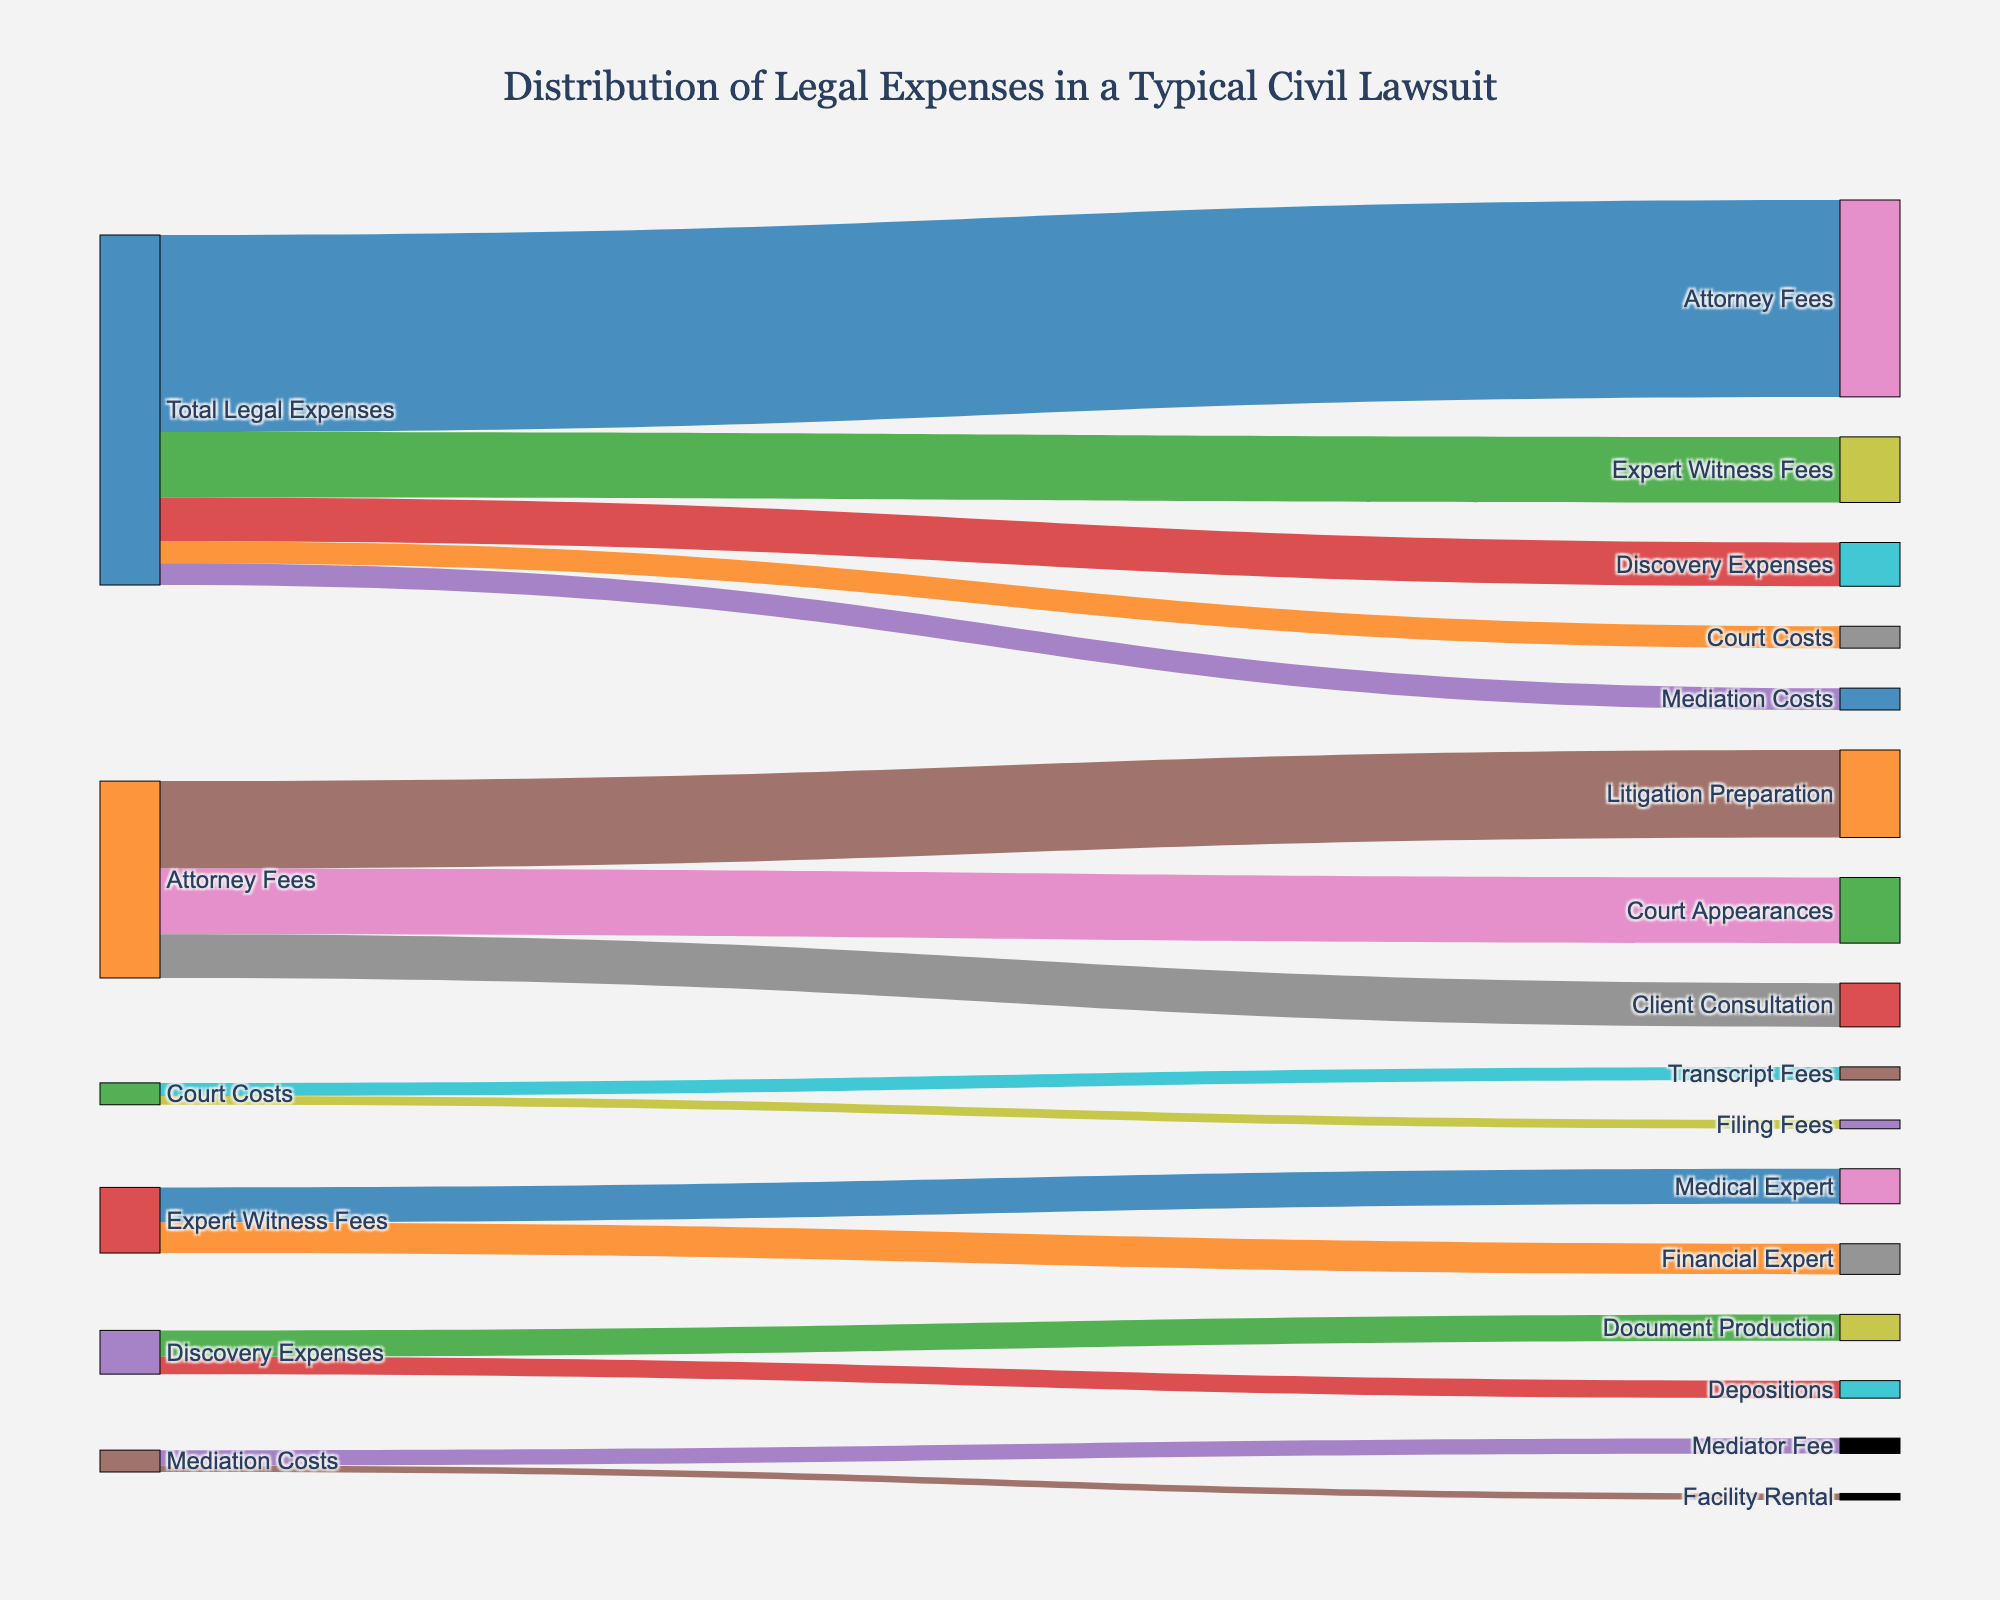What is the title of the figure? The title of the figure is located at the top center and gives an overview of the data being presented. By reading the title, one can identify the subject and context of the diagram.
Answer: Distribution of Legal Expenses in a Typical Civil Lawsuit How many main categories of legal expenses are there in the figure? By observing the nodes directly connected to "Total Legal Expenses," we can count the distinct categories of legal expenses. Each outgoing flow from the "Total Legal Expenses" node represents a main category.
Answer: 5 What is the total value of Attorney Fees? Identify all the subcategories of Attorney Fees and sum their values: Litigation Preparation (20000) + Court Appearances (15000) + Client Consultation (10000).
Answer: 45000 How does the value of Expert Witness Fees compare to Discovery Expenses? Look at the figures for Expert Witness Fees (15000) and Discovery Expenses (10000) directly on the visualized nodes. Compare these two values.
Answer: Expert Witness Fees (15000) are higher than Discovery Expenses (10000) What percentage of the total legal expenses is allocated to Court Costs? Sum the values for all main categories to get total legal expenses: 45000 + 5000 + 15000 + 10000 + 5000 = 80000. Then, calculate the percentage for Court Costs: (5000 / 80000) * 100.
Answer: 6.25% Which subcategory within Mediation Costs has a higher value, and by how much? Look at the values for Mediator Fee (3500) and Facility Rental (1500) directly on the diagram. Subtract the smaller value from the larger value to find the difference.
Answer: Mediator Fee is higher by 2000 If we combine the costs of Expert Witness Fees and Discovery Expenses, how much would they amount to? Sum the values of Expert Witness Fees (15000) and Discovery Expenses (10000) directly by following their paths on the diagram.
Answer: 25000 Which category has the smallest total value, and what is it? Compare the total values for all main categories: Attorney Fees (45000), Court Costs (5000), Expert Witness Fees (15000), Discovery Expenses (10000), Mediation Costs (5000). Identify the smallest value.
Answer: Court Costs (5000), Mediation Costs (5000) How does the cost of Medical Expert compare to Financial Expert within Expert Witness Fees? Find the values for Medical Expert (8000) and Financial Expert (7000) on the figure. Determine which is higher and by how much.
Answer: Medical Expert costs 1000 more than Financial Expert 